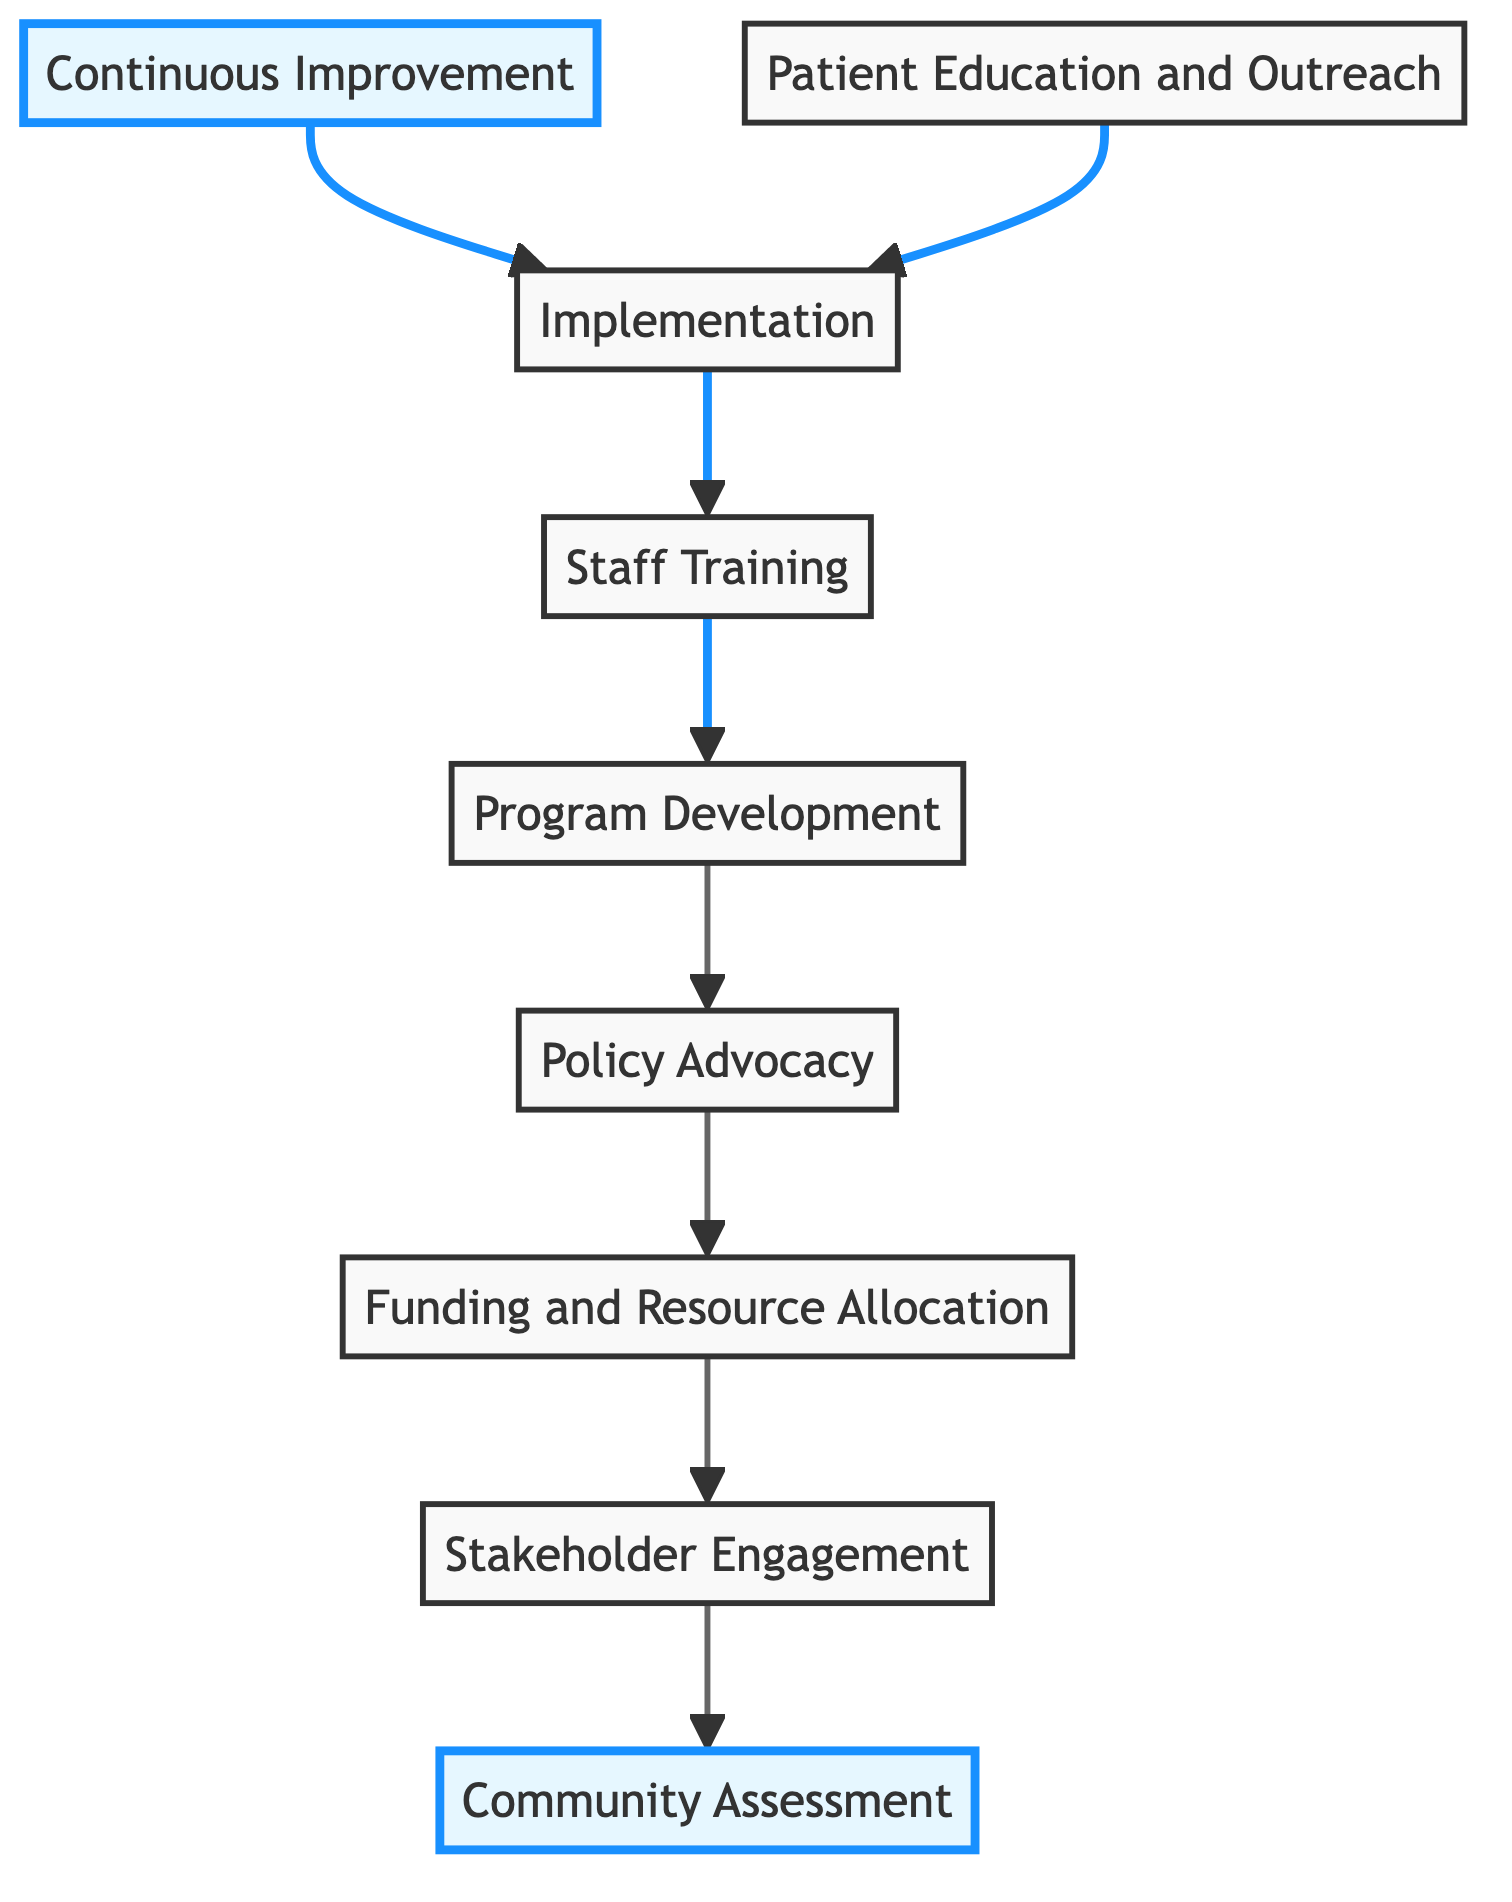What is the first step in the workflow? The first step in the workflow is labeled as "Community Assessment." It is located at the bottom of the flowchart and serves as the foundation for the subsequent steps to expand healthcare access.
Answer: Community Assessment How many nodes are present in the diagram? By counting each unique step in the workflow, we find that there are a total of 9 nodes, which represent specific actions or areas of focus in the process.
Answer: 9 Which step comes before "Implementation"? "Staff Training" is the step that comes immediately before "Implementation" in the workflow. This shows that staff must be trained before healthcare services are deployed in communities.
Answer: Staff Training What is the last step in the workflow? The last step in the workflow is "Continuous Improvement," indicating the continual feedback and enhancement of the healthcare programs. This step is at the very top of the flowchart, reflecting the ongoing nature of system improvement.
Answer: Continuous Improvement What is the relationship between "Policy Advocacy" and "Funding and Resource Allocation"? "Policy Advocacy" comes immediately after "Funding and Resource Allocation," indicating that securing funds is a precursor to advocating for legal changes to address systemic inequalities in healthcare access.
Answer: Sequential Which two steps connect directly to "Implementation"? The two steps that connect directly to "Implementation" are "Patient Education and Outreach" and "Staff Training." These connections illustrate that both educating the community and training staff are vital before implementing the services.
Answer: Patient Education and Outreach, Staff Training What action is taken after "Program Development"? After "Program Development," the next action is "Staff Training." This means that once programs are designed, training is provided to healthcare providers to ensure quality care.
Answer: Staff Training What is the primary goal of "Continuous Improvement"? The primary goal of "Continuous Improvement" is to collect feedback and data to enhance and adapt healthcare programs based on the community's evolving needs. This step emphasizes the importance of responsiveness in healthcare delivery.
Answer: Responsive adaptation How does "Stakeholder Engagement" influence the "Funding and Resource Allocation" step? "Stakeholder Engagement" influences "Funding and Resource Allocation" by gathering insights and support from local leaders and healthcare workers, which is essential for successfully securing the necessary funds for healthcare programs.
Answer: Influential support 